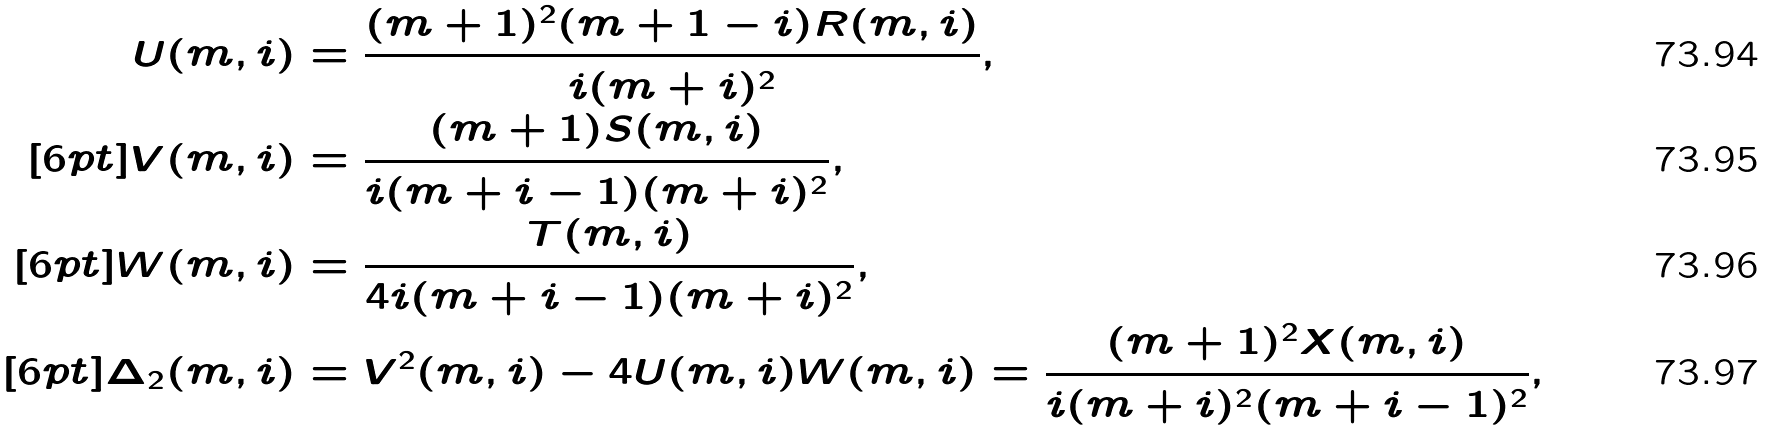<formula> <loc_0><loc_0><loc_500><loc_500>U ( m , i ) & = \frac { ( m + 1 ) ^ { 2 } ( m + 1 - i ) R ( m , i ) } { i ( m + i ) ^ { 2 } } , \\ [ 6 p t ] V ( m , i ) & = \frac { ( m + 1 ) S ( m , i ) } { i ( m + i - 1 ) ( m + i ) ^ { 2 } } , \\ [ 6 p t ] W ( m , i ) & = \frac { T ( m , i ) } { 4 i ( m + i - 1 ) ( m + i ) ^ { 2 } } , \\ [ 6 p t ] \Delta _ { 2 } ( m , i ) & = V ^ { 2 } ( m , i ) - 4 U ( m , i ) W ( m , i ) = \frac { ( m + 1 ) ^ { 2 } X ( m , i ) } { i ( m + i ) ^ { 2 } ( m + i - 1 ) ^ { 2 } } ,</formula> 